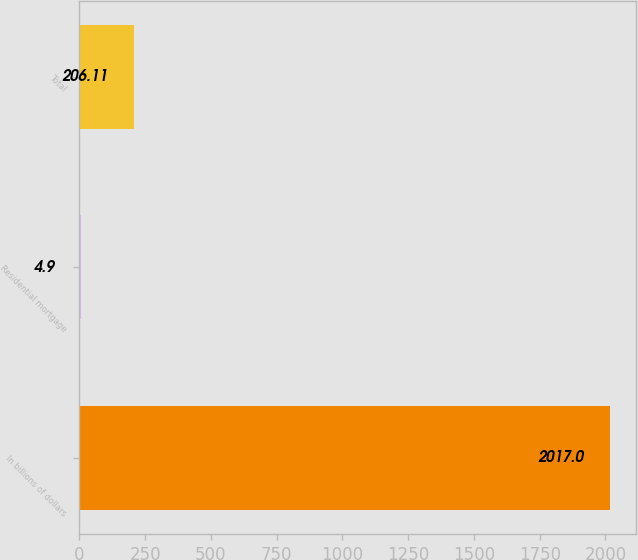Convert chart to OTSL. <chart><loc_0><loc_0><loc_500><loc_500><bar_chart><fcel>In billions of dollars<fcel>Residential mortgage<fcel>Total<nl><fcel>2017<fcel>4.9<fcel>206.11<nl></chart> 